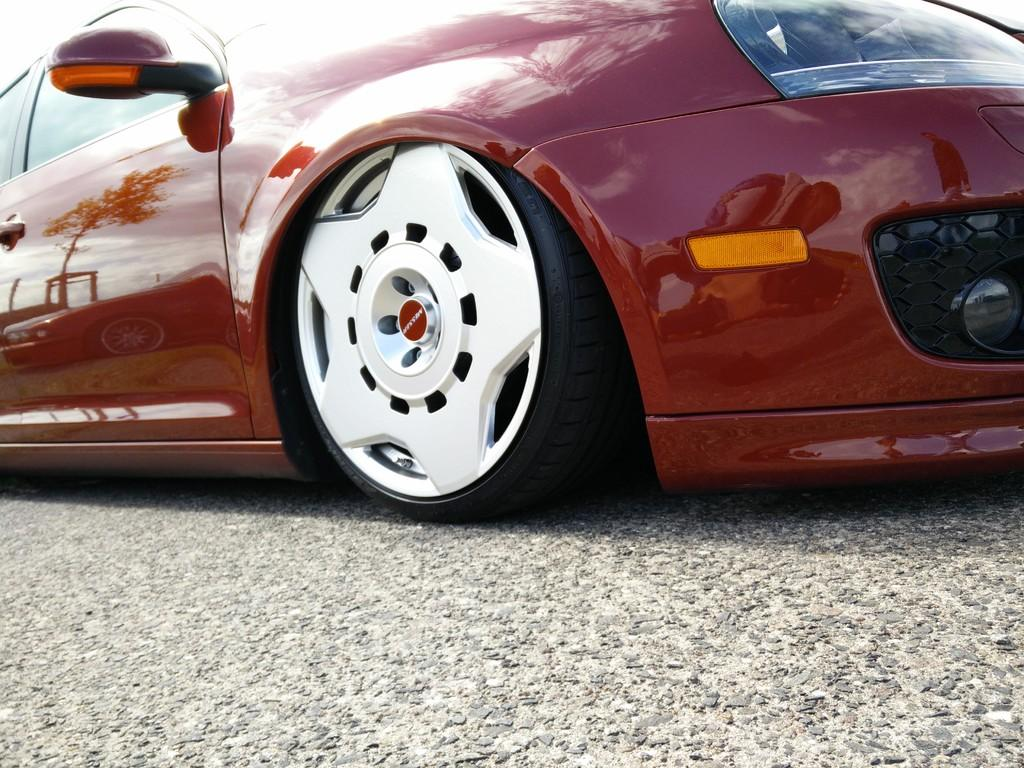What color is the car in the image? The car in the image is red. Where is the car located in the image? The car is parked on the road in the image. What is the surface on which the car is parked? The car is parked on the road, which is visible at the bottom of the image. What type of nerve is responsible for the car's movement in the image? There are no nerves present in the image, as it is a photograph of a car. The car's movement is not controlled by a nerve but by its engine and other mechanical components. 